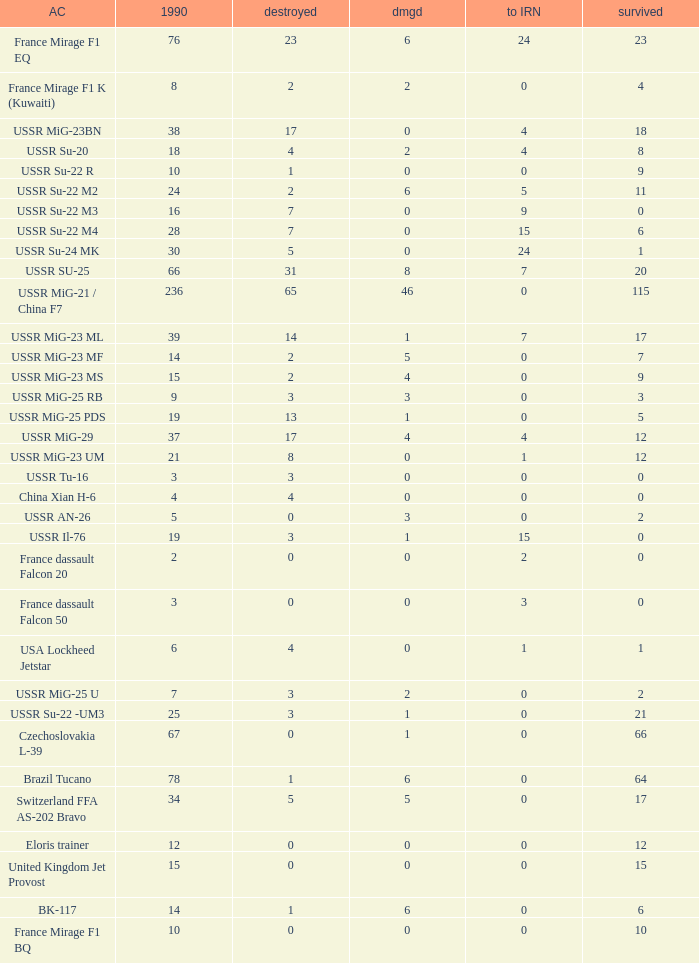If 4 went to iran and the amount that survived was less than 12.0 how many were there in 1990? 1.0. 